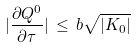Convert formula to latex. <formula><loc_0><loc_0><loc_500><loc_500>| \frac { \partial Q ^ { 0 } } { \partial \tau } | \, \leq \, b \sqrt { | K _ { 0 } | }</formula> 